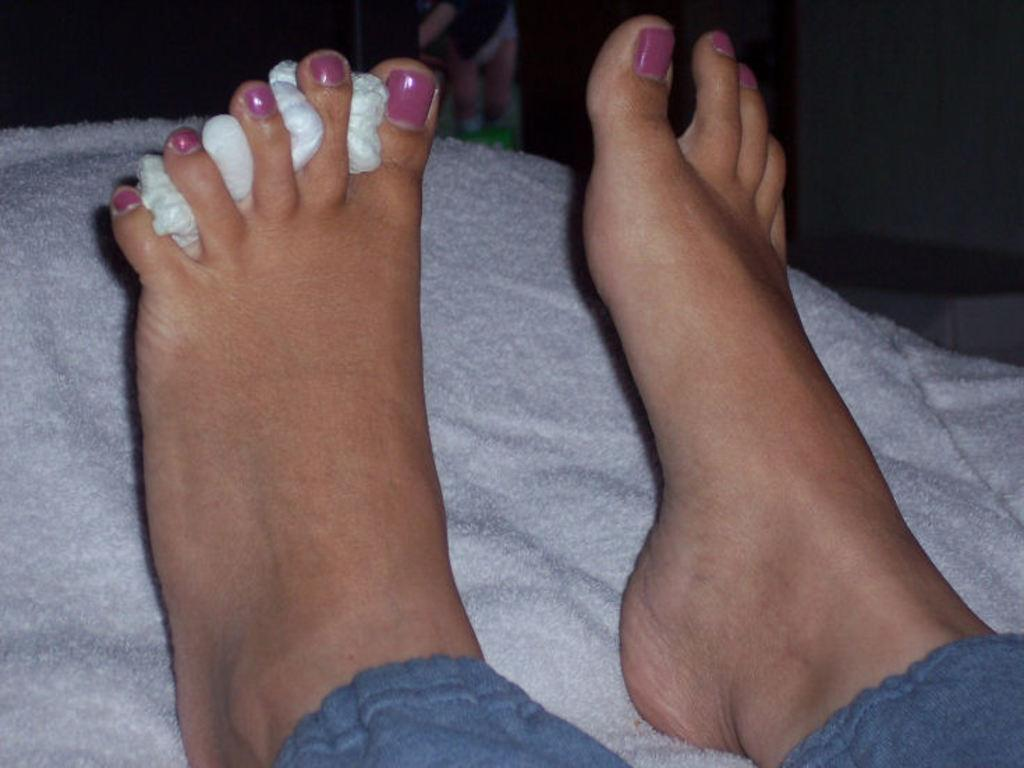What part of a person's body is visible in the image? There is a person's legs in the image. What color are the clothes that the person's legs are on? The person's legs are on white clothes. Can you describe the background of the image? The background of the image is dark. What is the taste of the queen's sweater in the image? There is no queen or sweater present in the image, so it is not possible to determine the taste of a sweater. 